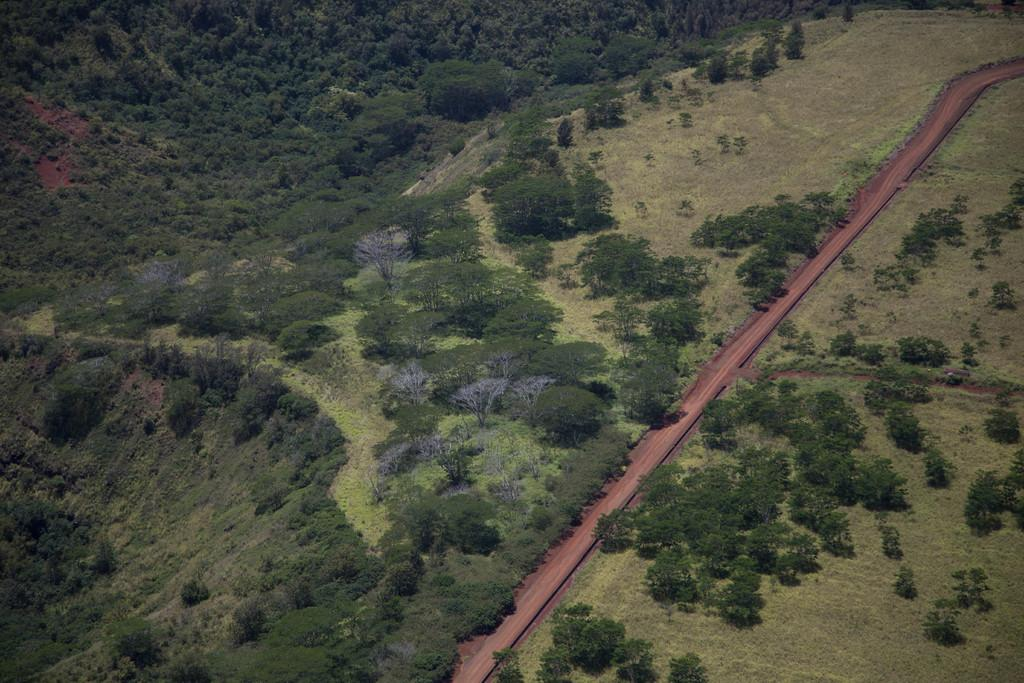What type of vegetation is present in the image? There are trees and grass in the image. What type of terrain is visible in the image? There is a road and mountains in the image. Can you describe the natural setting in the image? The image may have been taken near a hill station, as it features trees, grass, mountains, and a road. What color is the vein visible on the beetle in the image? There is no beetle or vein present in the image. Is there a glove visible in the image? There is no glove present in the image. 